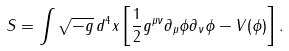Convert formula to latex. <formula><loc_0><loc_0><loc_500><loc_500>S = \int \sqrt { - g } \, d ^ { 4 } x \left [ \frac { 1 } { 2 } g ^ { \mu \nu } \partial _ { \mu } \phi \partial _ { \nu } \phi - V ( \phi ) \right ] .</formula> 